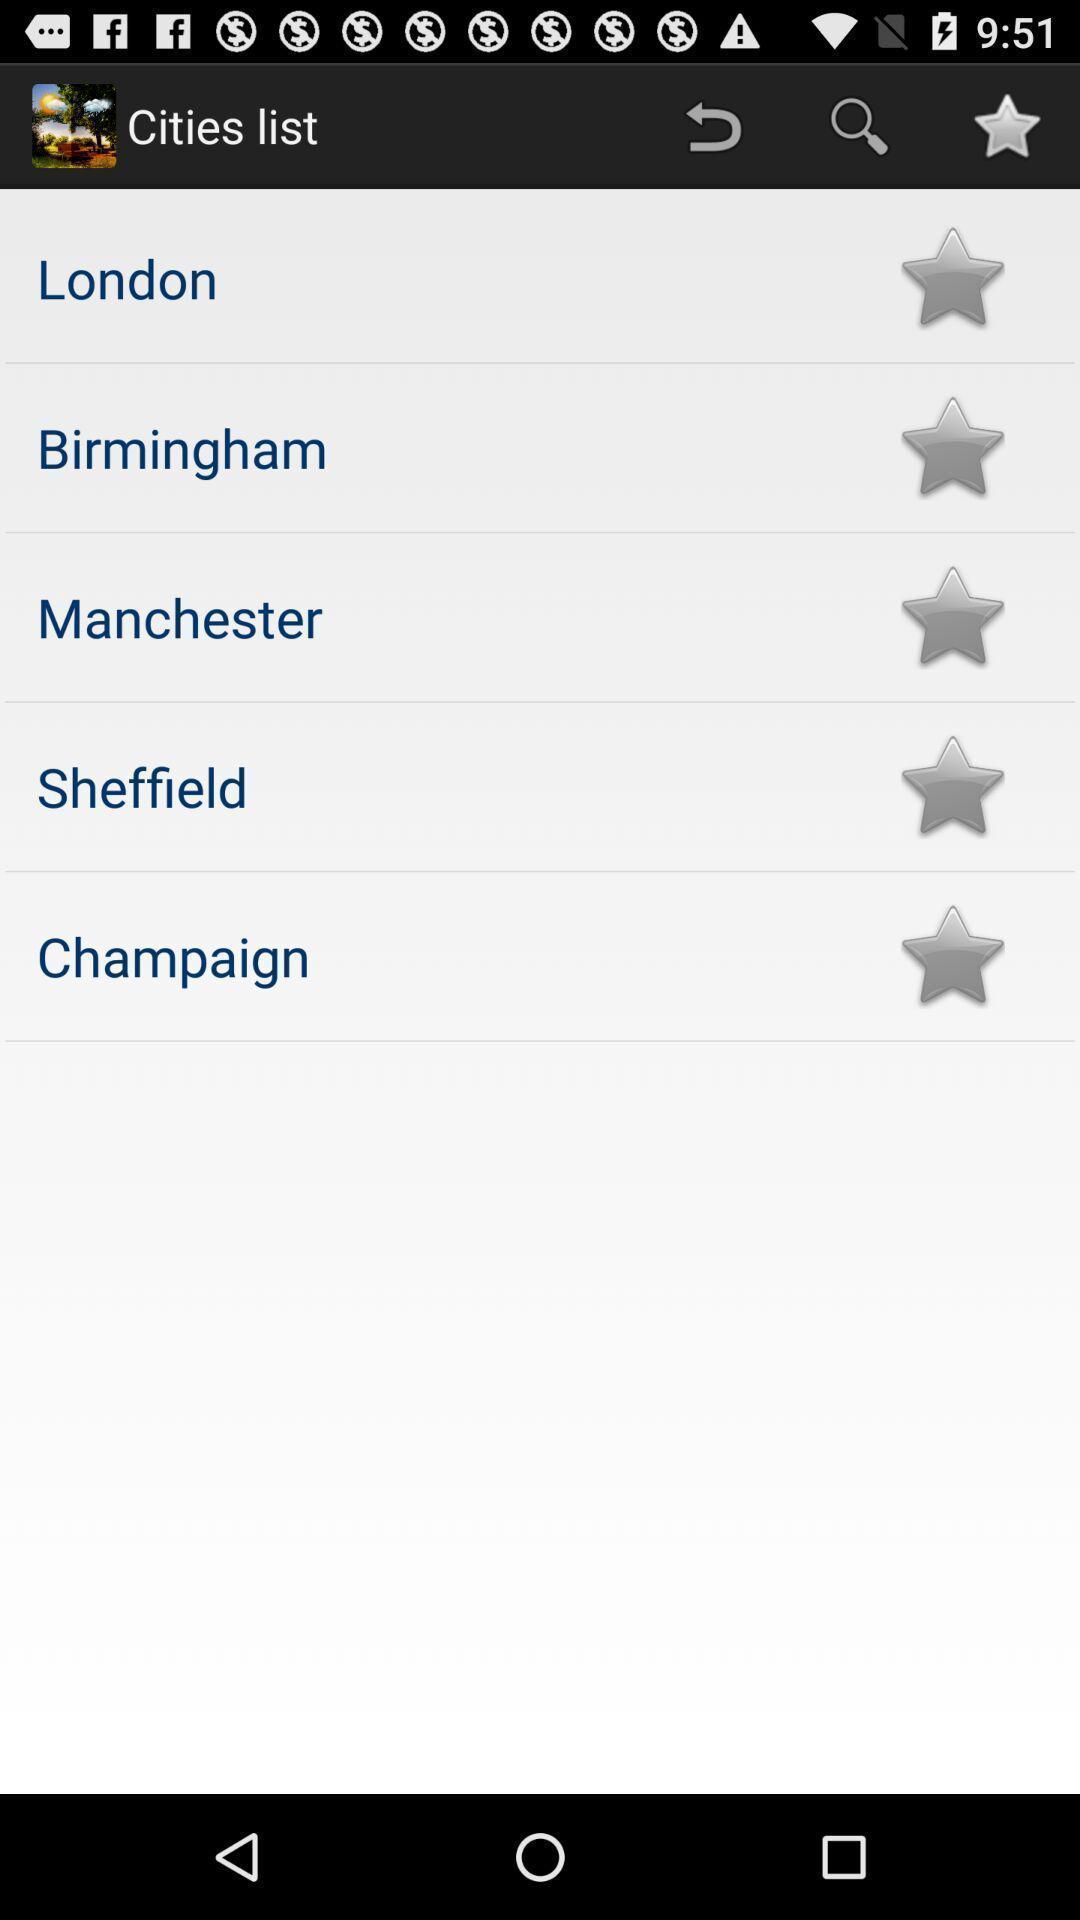Describe the content in this image. Screen displaying a list of city names. 